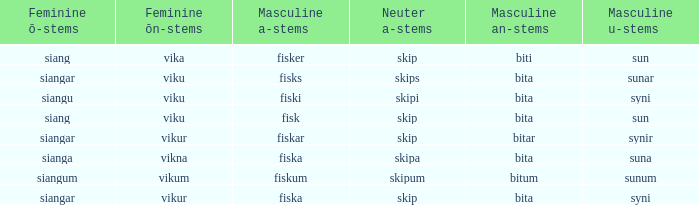What is the masculine u form for the old Swedish word with a neuter a form of skipum? Sunum. 